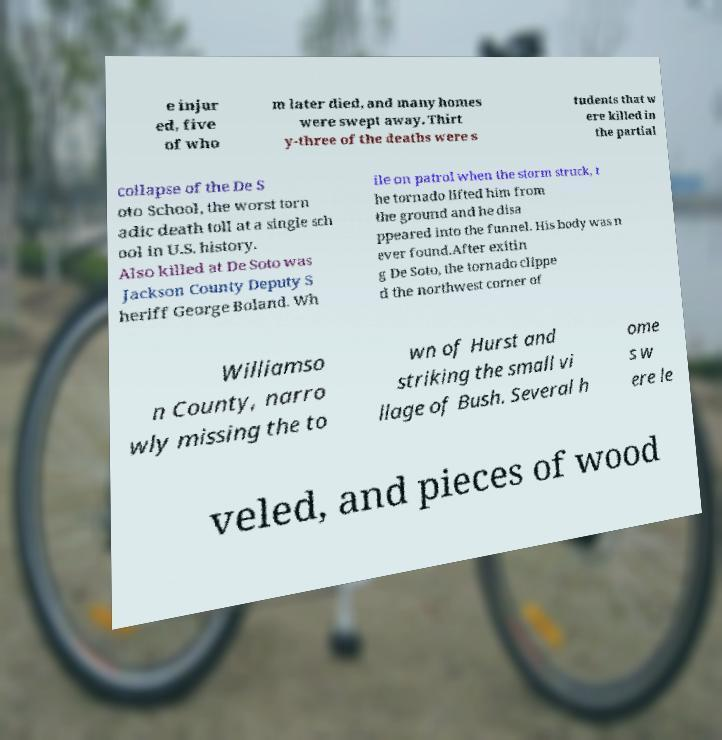What messages or text are displayed in this image? I need them in a readable, typed format. e injur ed, five of who m later died, and many homes were swept away. Thirt y-three of the deaths were s tudents that w ere killed in the partial collapse of the De S oto School, the worst torn adic death toll at a single sch ool in U.S. history. Also killed at De Soto was Jackson County Deputy S heriff George Boland. Wh ile on patrol when the storm struck, t he tornado lifted him from the ground and he disa ppeared into the funnel. His body was n ever found.After exitin g De Soto, the tornado clippe d the northwest corner of Williamso n County, narro wly missing the to wn of Hurst and striking the small vi llage of Bush. Several h ome s w ere le veled, and pieces of wood 